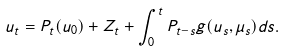Convert formula to latex. <formula><loc_0><loc_0><loc_500><loc_500>u _ { t } = P _ { t } ( u _ { 0 } ) + Z _ { t } + \int _ { 0 } ^ { t } P _ { t - s } g ( u _ { s } , \mu _ { s } ) d s .</formula> 